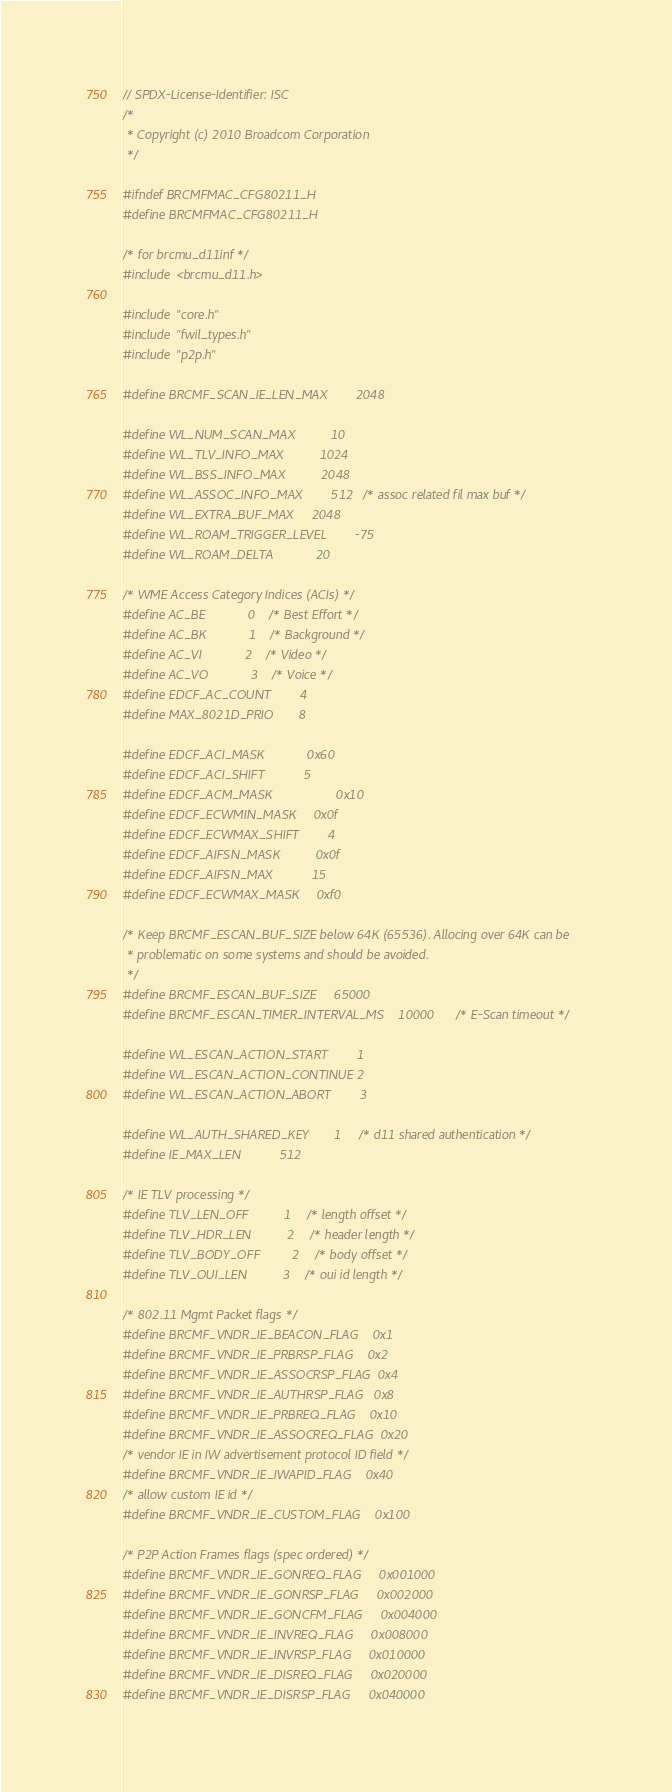Convert code to text. <code><loc_0><loc_0><loc_500><loc_500><_C_>// SPDX-License-Identifier: ISC
/*
 * Copyright (c) 2010 Broadcom Corporation
 */

#ifndef BRCMFMAC_CFG80211_H
#define BRCMFMAC_CFG80211_H

/* for brcmu_d11inf */
#include <brcmu_d11.h>

#include "core.h"
#include "fwil_types.h"
#include "p2p.h"

#define BRCMF_SCAN_IE_LEN_MAX		2048

#define WL_NUM_SCAN_MAX			10
#define WL_TLV_INFO_MAX			1024
#define WL_BSS_INFO_MAX			2048
#define WL_ASSOC_INFO_MAX		512	/* assoc related fil max buf */
#define WL_EXTRA_BUF_MAX		2048
#define WL_ROAM_TRIGGER_LEVEL		-75
#define WL_ROAM_DELTA			20

/* WME Access Category Indices (ACIs) */
#define AC_BE			0	/* Best Effort */
#define AC_BK			1	/* Background */
#define AC_VI			2	/* Video */
#define AC_VO			3	/* Voice */
#define EDCF_AC_COUNT		4
#define MAX_8021D_PRIO		8

#define EDCF_ACI_MASK			0x60
#define EDCF_ACI_SHIFT			5
#define EDCF_ACM_MASK                  0x10
#define EDCF_ECWMIN_MASK		0x0f
#define EDCF_ECWMAX_SHIFT		4
#define EDCF_AIFSN_MASK			0x0f
#define EDCF_AIFSN_MAX			15
#define EDCF_ECWMAX_MASK		0xf0

/* Keep BRCMF_ESCAN_BUF_SIZE below 64K (65536). Allocing over 64K can be
 * problematic on some systems and should be avoided.
 */
#define BRCMF_ESCAN_BUF_SIZE		65000
#define BRCMF_ESCAN_TIMER_INTERVAL_MS	10000	/* E-Scan timeout */

#define WL_ESCAN_ACTION_START		1
#define WL_ESCAN_ACTION_CONTINUE	2
#define WL_ESCAN_ACTION_ABORT		3

#define WL_AUTH_SHARED_KEY		1	/* d11 shared authentication */
#define IE_MAX_LEN			512

/* IE TLV processing */
#define TLV_LEN_OFF			1	/* length offset */
#define TLV_HDR_LEN			2	/* header length */
#define TLV_BODY_OFF			2	/* body offset */
#define TLV_OUI_LEN			3	/* oui id length */

/* 802.11 Mgmt Packet flags */
#define BRCMF_VNDR_IE_BEACON_FLAG	0x1
#define BRCMF_VNDR_IE_PRBRSP_FLAG	0x2
#define BRCMF_VNDR_IE_ASSOCRSP_FLAG	0x4
#define BRCMF_VNDR_IE_AUTHRSP_FLAG	0x8
#define BRCMF_VNDR_IE_PRBREQ_FLAG	0x10
#define BRCMF_VNDR_IE_ASSOCREQ_FLAG	0x20
/* vendor IE in IW advertisement protocol ID field */
#define BRCMF_VNDR_IE_IWAPID_FLAG	0x40
/* allow custom IE id */
#define BRCMF_VNDR_IE_CUSTOM_FLAG	0x100

/* P2P Action Frames flags (spec ordered) */
#define BRCMF_VNDR_IE_GONREQ_FLAG     0x001000
#define BRCMF_VNDR_IE_GONRSP_FLAG     0x002000
#define BRCMF_VNDR_IE_GONCFM_FLAG     0x004000
#define BRCMF_VNDR_IE_INVREQ_FLAG     0x008000
#define BRCMF_VNDR_IE_INVRSP_FLAG     0x010000
#define BRCMF_VNDR_IE_DISREQ_FLAG     0x020000
#define BRCMF_VNDR_IE_DISRSP_FLAG     0x040000</code> 